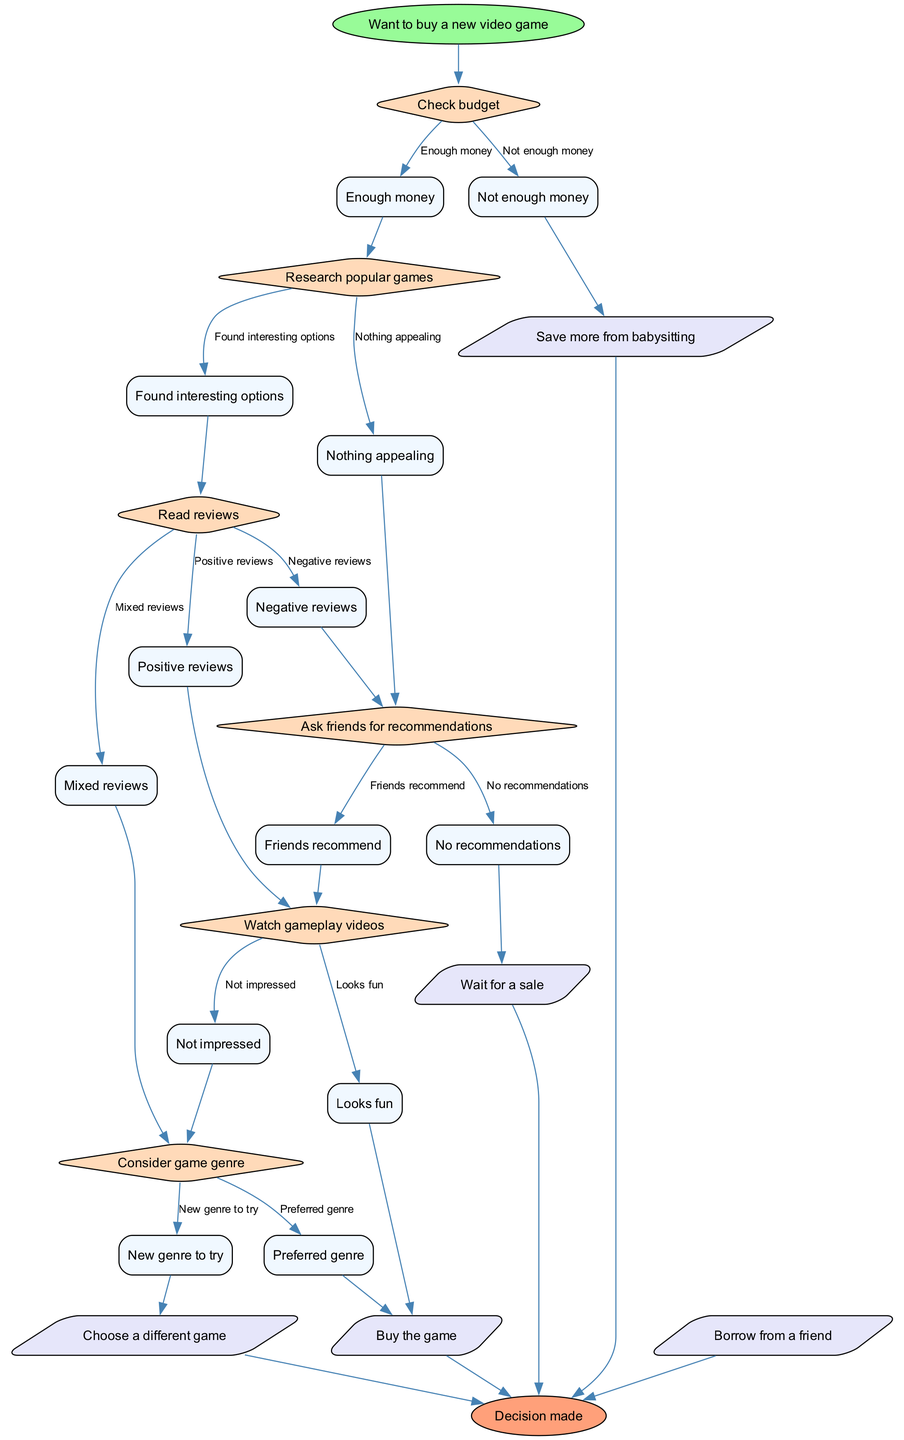What is the starting point of the flow chart? The starting point of the flow chart is indicated by the "Want to buy a new video game" node, which initiates the decision-making process.
Answer: Want to buy a new video game How many decision nodes are present in the flow chart? By counting the nodes designated for decision-making (represented as diamonds), I can see there are six decision nodes in total.
Answer: 6 What action node follows after finding interesting options? The flow chart indicates that after finding interesting options, the next action involves reading reviews, which is the subsequent decision step.
Answer: Read reviews If I don't have enough money, what is my first action? According to the chart, the first action if lacking adequate funds is to save more from babysitting, prioritizing financial readiness before making a game purchase.
Answer: Save more from babysitting How many edges lead out from the "Read reviews" node? The edges leading out from the "Read reviews" decision node are three in number, representing the possible outcomes of reviews being positive, mixed, or negative.
Answer: 3 What happens if my friends recommend a game? If friends recommend a game, the next action is to watch gameplay videos, as shown in the flow of the decision-making process.
Answer: Watch gameplay If I want to try a new genre, what is the resulting action? If I consider a new genre to try, the action leading from that decision is to choose a different game, indicating a willingness to explore beyond familiar choices.
Answer: Choose a different game What is the final outcome of the decision-making process? The flow chart concludes with the final outcome stated as "Decision made," indicating that a choice has been reached after navigating through the decision-making steps.
Answer: Decision made What should you do if the gameplay isn't impressive? According to the flow, if the gameplay videos do not impress, the subsequent decision is to consider the genre of the game, weighing options based on genre suitability.
Answer: Consider game genre What is the consequence of negative reviews? If negative reviews are encountered, the outcome leads to asking friends for recommendations as an attempt to find alternative game options through peer input.
Answer: Ask friends for recommendations 